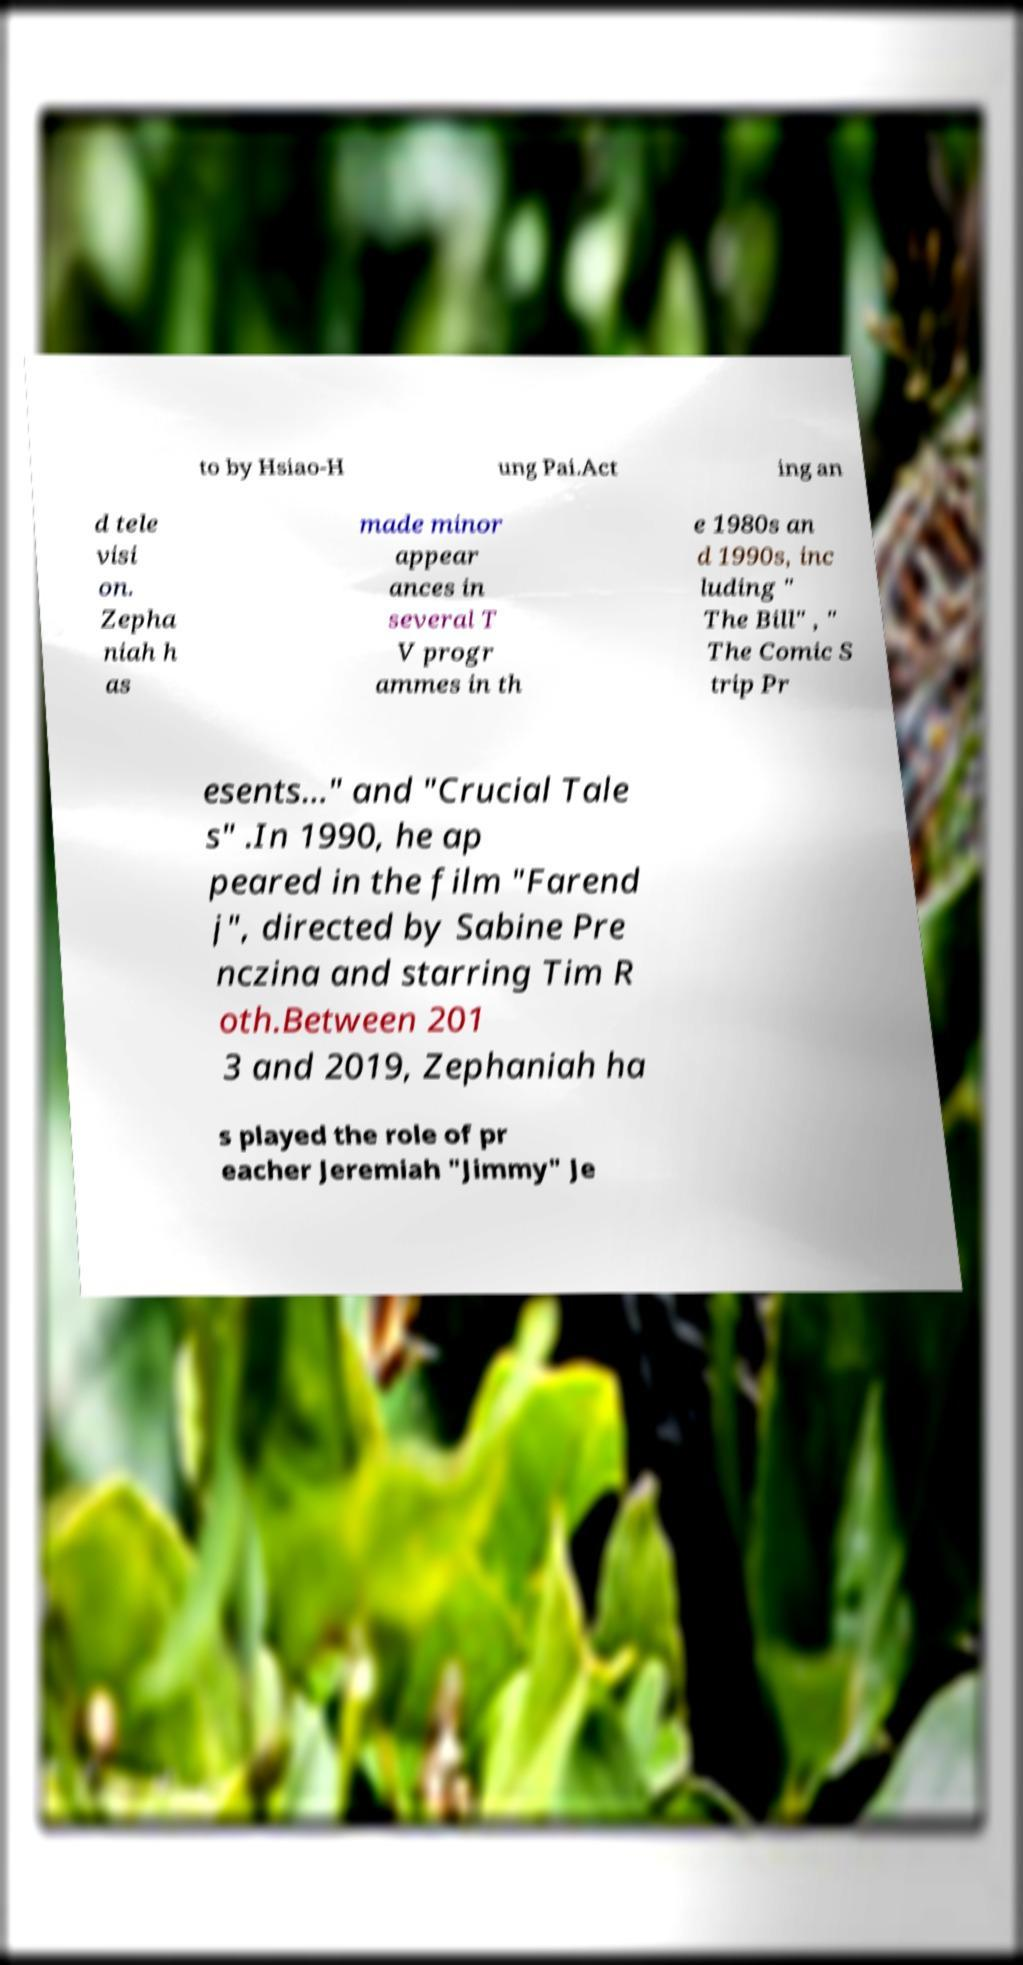Please identify and transcribe the text found in this image. to by Hsiao-H ung Pai.Act ing an d tele visi on. Zepha niah h as made minor appear ances in several T V progr ammes in th e 1980s an d 1990s, inc luding " The Bill" , " The Comic S trip Pr esents..." and "Crucial Tale s" .In 1990, he ap peared in the film "Farend j", directed by Sabine Pre nczina and starring Tim R oth.Between 201 3 and 2019, Zephaniah ha s played the role of pr eacher Jeremiah "Jimmy" Je 